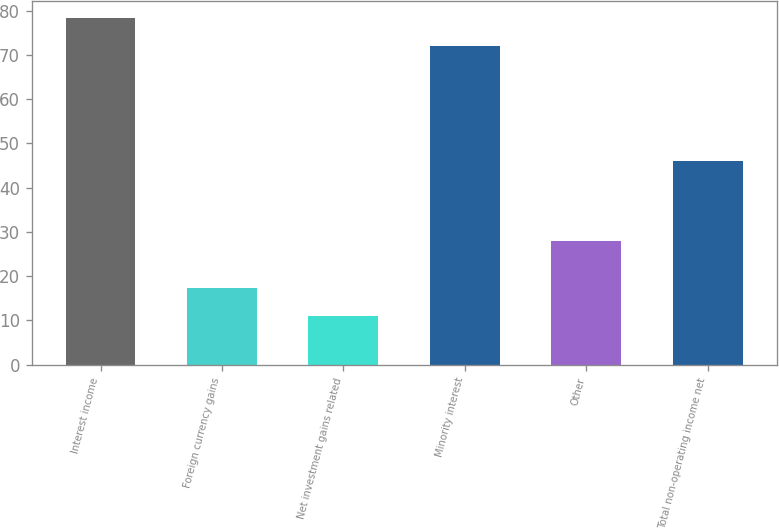Convert chart to OTSL. <chart><loc_0><loc_0><loc_500><loc_500><bar_chart><fcel>Interest income<fcel>Foreign currency gains<fcel>Net investment gains related<fcel>Minority interest<fcel>Other<fcel>Total non-operating income net<nl><fcel>78.3<fcel>17.3<fcel>11<fcel>72<fcel>28<fcel>46<nl></chart> 